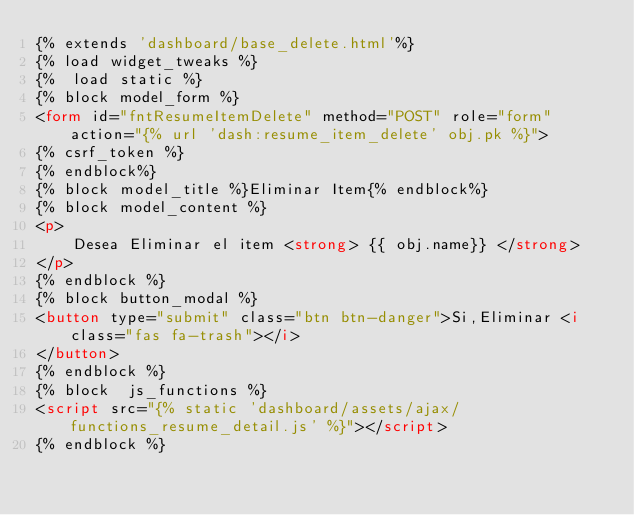Convert code to text. <code><loc_0><loc_0><loc_500><loc_500><_HTML_>{% extends 'dashboard/base_delete.html'%}
{% load widget_tweaks %}
{%  load static %}
{% block model_form %}
<form id="fntResumeItemDelete" method="POST" role="form"  action="{% url 'dash:resume_item_delete' obj.pk %}">
{% csrf_token %}
{% endblock%}
{% block model_title %}Eliminar Item{% endblock%}
{% block model_content %}
<p>
    Desea Eliminar el item <strong> {{ obj.name}} </strong>
</p>                
{% endblock %}
{% block button_modal %}
<button type="submit" class="btn btn-danger">Si,Eliminar <i class="fas fa-trash"></i>
</button>   
{% endblock %}
{% block  js_functions %}
<script src="{% static 'dashboard/assets/ajax/functions_resume_detail.js' %}"></script>
{% endblock %}    
</code> 